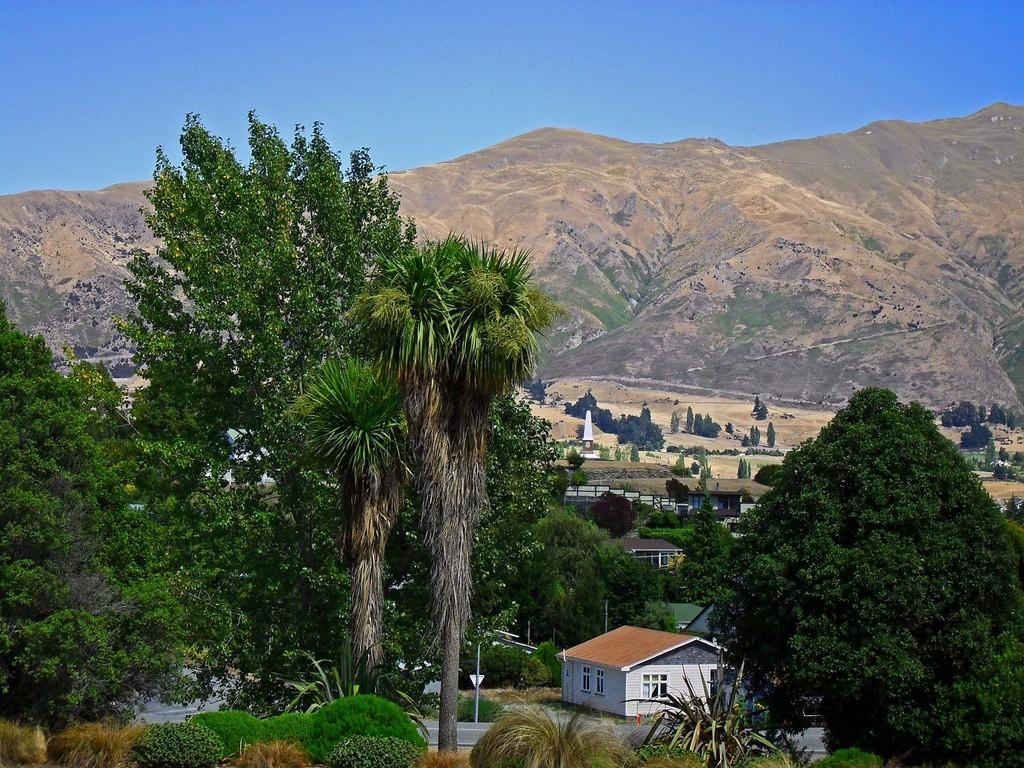What can be seen in the sky in the image? The sky is visible in the image. What type of natural landform is present in the image? There are hills in the image. What type of man-made structures can be seen in the image? There are buildings in the image. What type of urban infrastructure is present in the image? Street poles are present in the image. What type of vegetation is visible in the image? Trees and bushes are visible in the image. What type of transportation infrastructure is present in the image? There is a road in the image. What language is spoken by the aunt in the image? There is no aunt present in the image, so it is not possible to determine what language she might speak. What type of pump is visible in the image? There is no pump present in the image. 